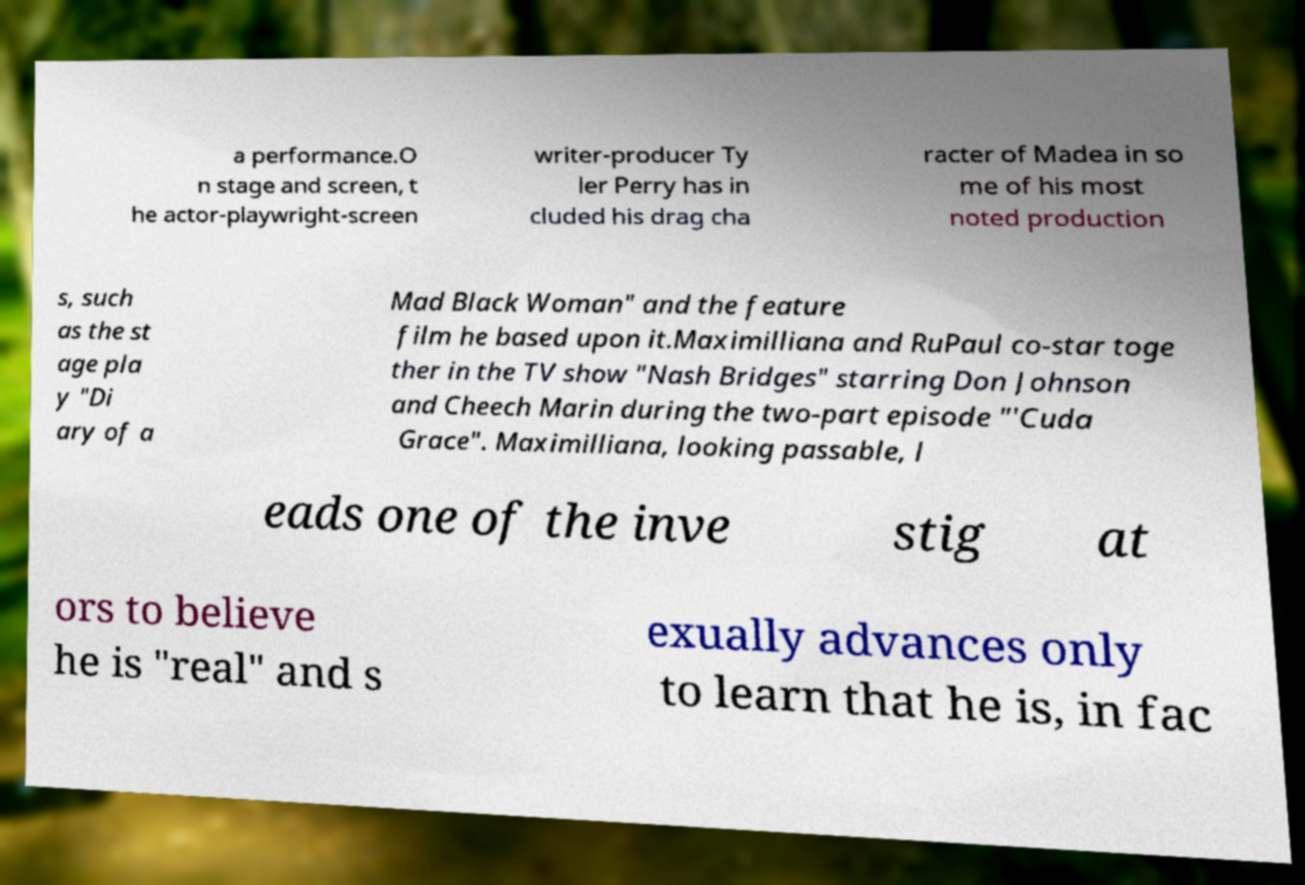What messages or text are displayed in this image? I need them in a readable, typed format. a performance.O n stage and screen, t he actor-playwright-screen writer-producer Ty ler Perry has in cluded his drag cha racter of Madea in so me of his most noted production s, such as the st age pla y "Di ary of a Mad Black Woman" and the feature film he based upon it.Maximilliana and RuPaul co-star toge ther in the TV show "Nash Bridges" starring Don Johnson and Cheech Marin during the two-part episode "'Cuda Grace". Maximilliana, looking passable, l eads one of the inve stig at ors to believe he is "real" and s exually advances only to learn that he is, in fac 